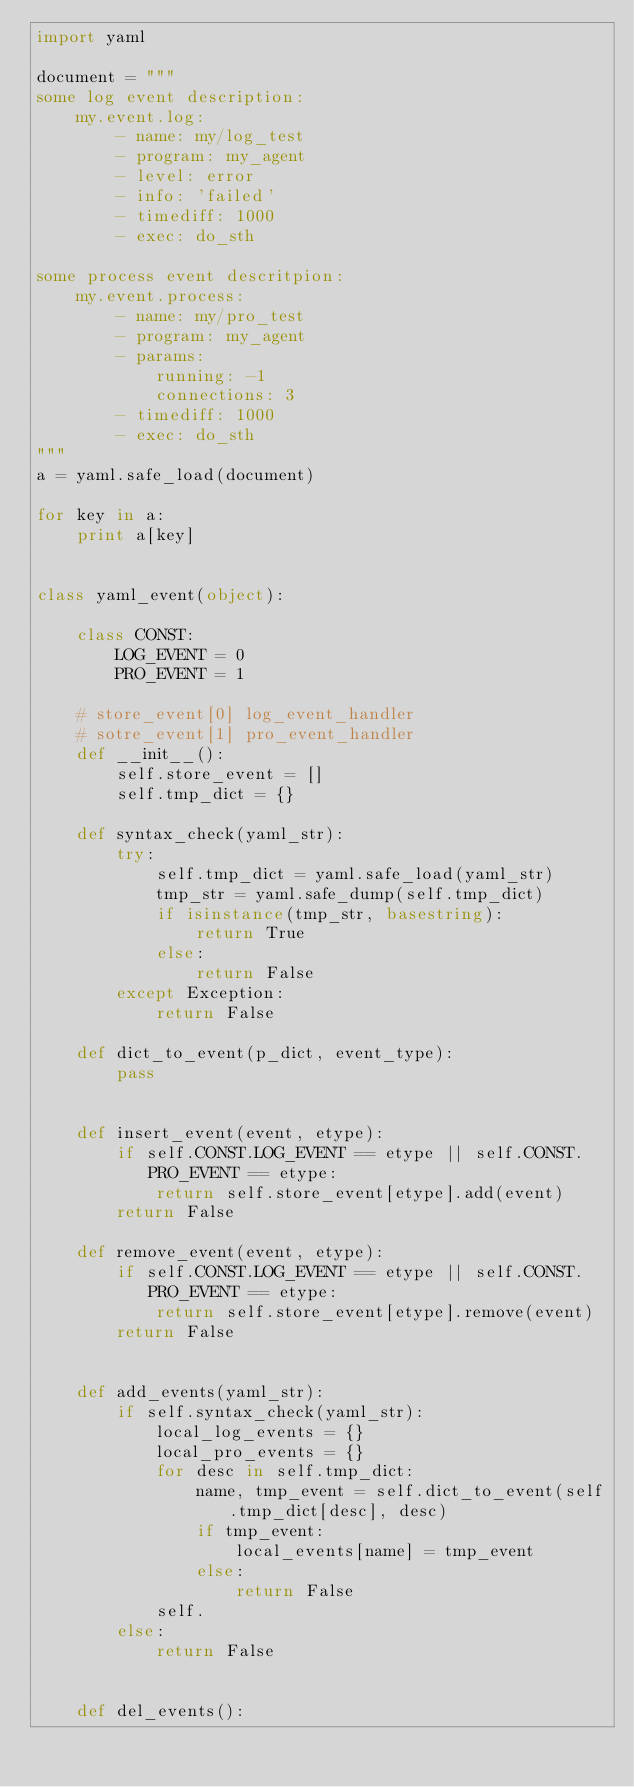<code> <loc_0><loc_0><loc_500><loc_500><_Python_>import yaml

document = """
some log event description:
    my.event.log:
        - name: my/log_test
        - program: my_agent
        - level: error
        - info: 'failed'
        - timediff: 1000
        - exec: do_sth

some process event descritpion:
    my.event.process:
        - name: my/pro_test
        - program: my_agent
        - params:
            running: -1
            connections: 3
        - timediff: 1000
        - exec: do_sth
"""
a = yaml.safe_load(document)

for key in a:
    print a[key]


class yaml_event(object):

    class CONST:
        LOG_EVENT = 0
        PRO_EVENT = 1

    # store_event[0] log_event_handler
    # sotre_event[1] pro_event_handler
    def __init__():
        self.store_event = []
        self.tmp_dict = {}

    def syntax_check(yaml_str):
        try:
            self.tmp_dict = yaml.safe_load(yaml_str)
            tmp_str = yaml.safe_dump(self.tmp_dict)
            if isinstance(tmp_str, basestring):
                return True
            else:
                return False
        except Exception:
            return False

    def dict_to_event(p_dict, event_type):
        pass


    def insert_event(event, etype):
        if self.CONST.LOG_EVENT == etype || self.CONST.PRO_EVENT == etype:
            return self.store_event[etype].add(event)
        return False

    def remove_event(event, etype):
        if self.CONST.LOG_EVENT == etype || self.CONST.PRO_EVENT == etype:
            return self.store_event[etype].remove(event)
        return False


    def add_events(yaml_str):
        if self.syntax_check(yaml_str):
            local_log_events = {}
            local_pro_events = {}
            for desc in self.tmp_dict:
                name, tmp_event = self.dict_to_event(self.tmp_dict[desc], desc)
                if tmp_event:
                    local_events[name] = tmp_event
                else:
                    return False
            self.
        else:
            return False    


    def del_events():</code> 